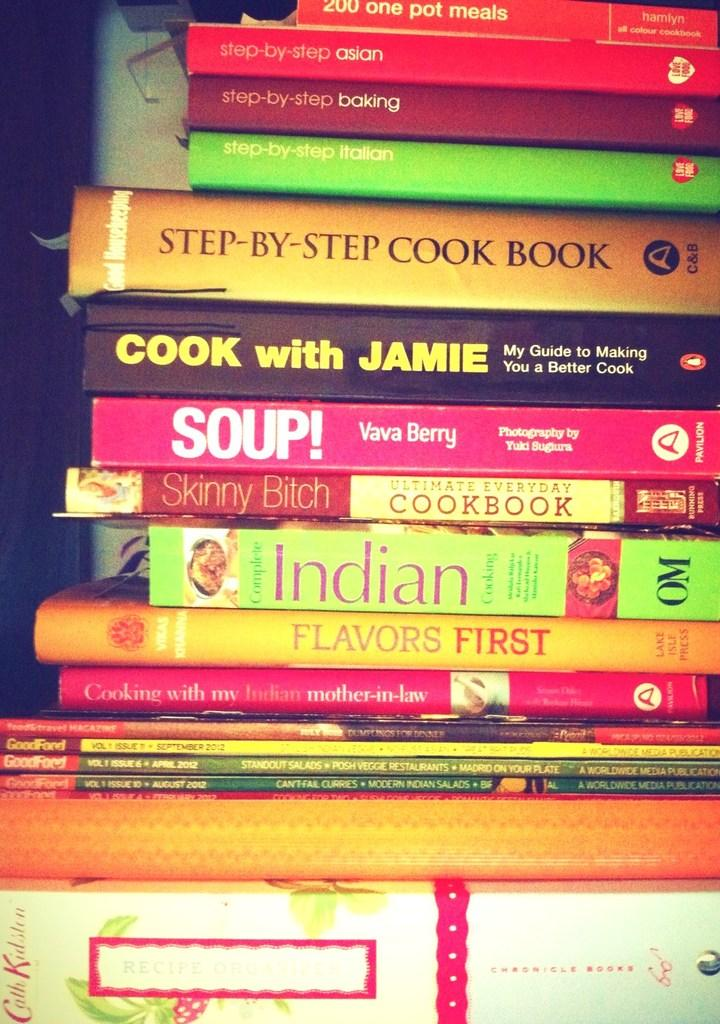<image>
Share a concise interpretation of the image provided. A stack of cookbooks from various cuisines ad authors. 